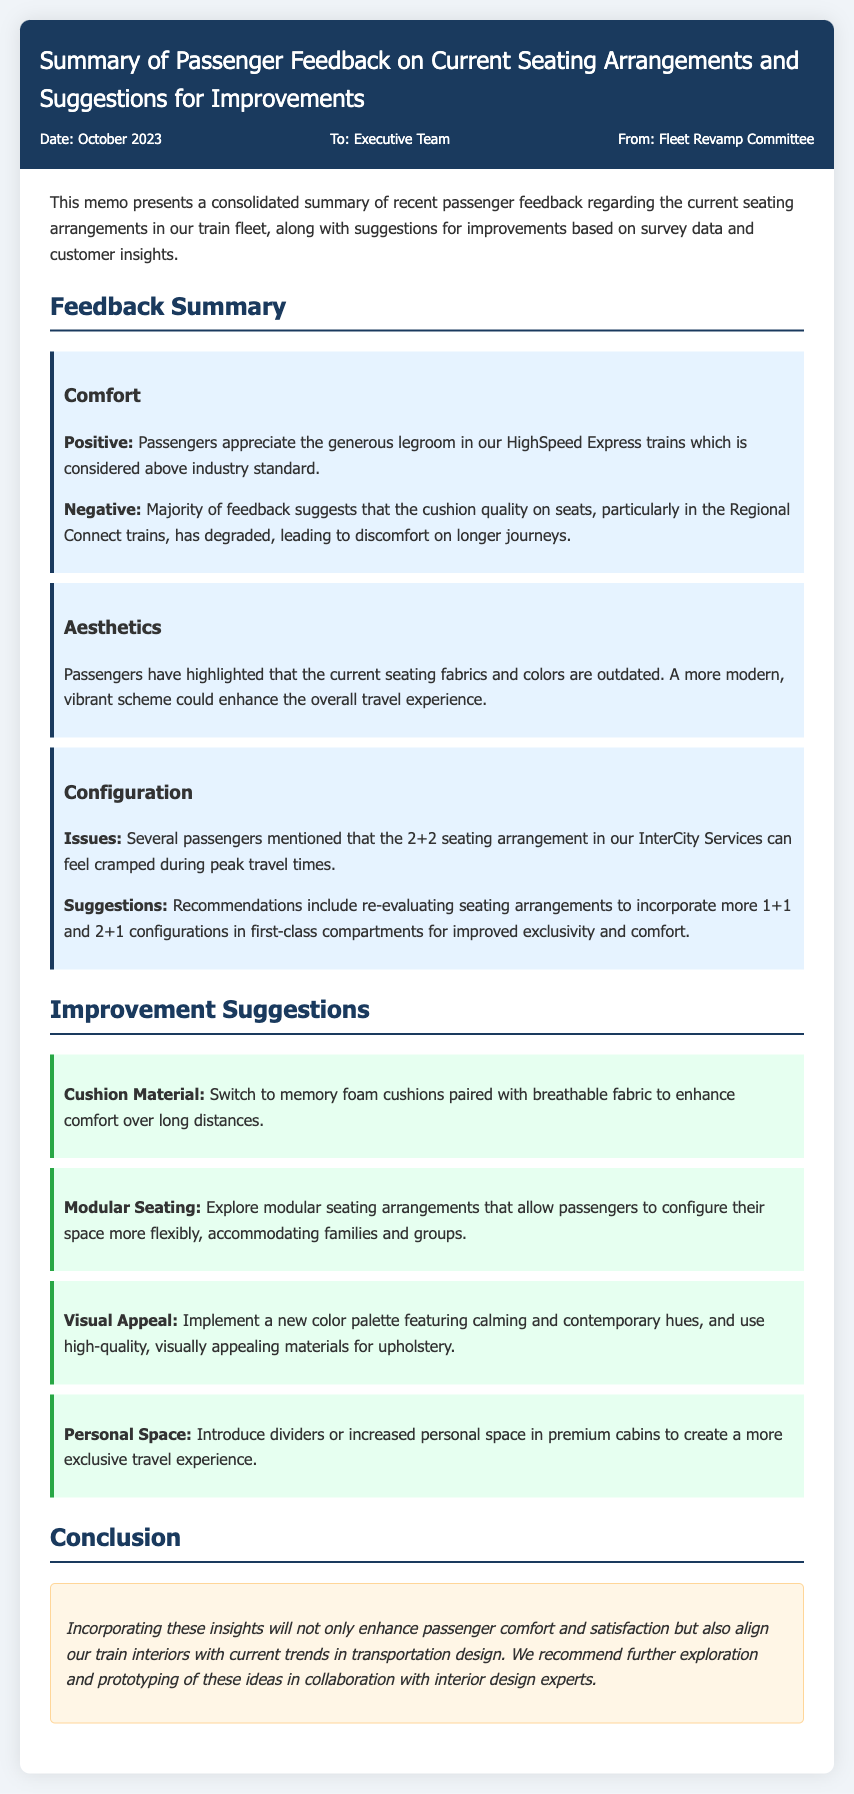What date was the memo created? The date of the memo is specified in the document's meta section as October 2023.
Answer: October 2023 Who is the memo addressed to? The recipient of the memo is mentioned in the meta section as the Executive Team.
Answer: Executive Team What is one positive aspect of the seating arrangements? The document states that passengers appreciate the generous legroom in HighSpeed Express trains.
Answer: Generous legroom What seating configuration is suggested for improved comfort? The memo suggests incorporating 1+1 and 2+1 configurations in first-class compartments.
Answer: 1+1 and 2+1 configurations What type of cushion material is recommended? The memo recommends switching to memory foam cushions for enhanced comfort.
Answer: Memory foam cushions What is the main conclusion of the memo? The conclusion emphasizes enhancing passenger comfort and satisfaction by implementing the suggestions.
Answer: Enhance passenger comfort and satisfaction What aspect of the current seating do passengers find outdated? Passengers have noted that the seating fabrics and colors are outdated and could be modernized.
Answer: Fabrics and colors What improvement is suggested for personal space in premium cabins? The document suggests introducing dividers or increased personal space in premium cabins.
Answer: Dividers or increased personal space 